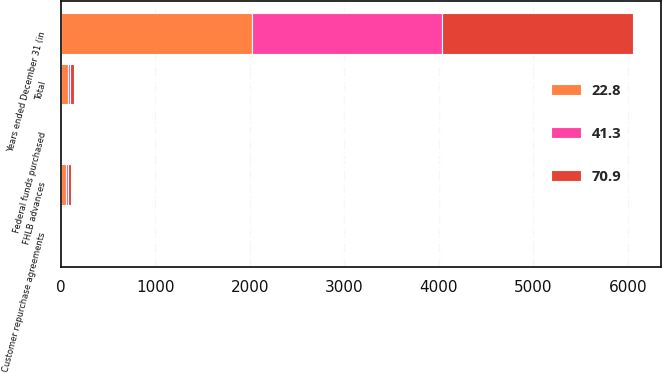Convert chart. <chart><loc_0><loc_0><loc_500><loc_500><stacked_bar_chart><ecel><fcel>Years ended December 31 (in<fcel>FHLB advances<fcel>Federal funds purchased<fcel>Customer repurchase agreements<fcel>Total<nl><fcel>22.8<fcel>2018<fcel>54.5<fcel>13.6<fcel>1<fcel>70.9<nl><fcel>70.9<fcel>2017<fcel>31.5<fcel>7.1<fcel>0.6<fcel>41.3<nl><fcel>41.3<fcel>2016<fcel>19.3<fcel>2.9<fcel>0.6<fcel>22.8<nl></chart> 